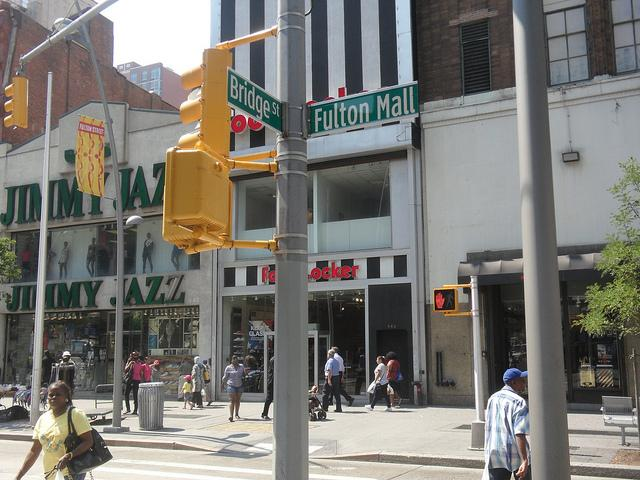Where should you go from the traffic light if you want to go to Fulton Mall?

Choices:
A) go back
B) turn left
C) go straight
D) turn right turn right 